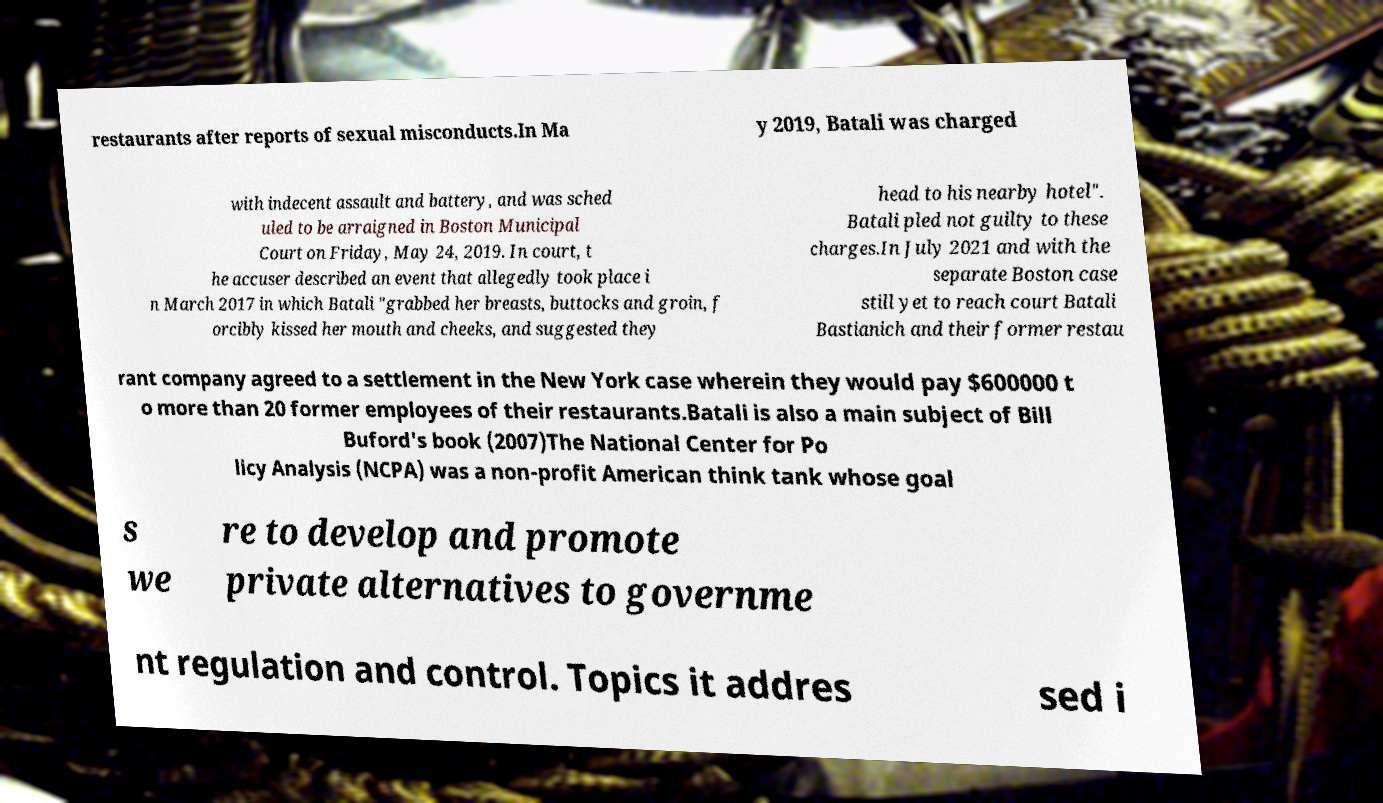I need the written content from this picture converted into text. Can you do that? restaurants after reports of sexual misconducts.In Ma y 2019, Batali was charged with indecent assault and battery, and was sched uled to be arraigned in Boston Municipal Court on Friday, May 24, 2019. In court, t he accuser described an event that allegedly took place i n March 2017 in which Batali "grabbed her breasts, buttocks and groin, f orcibly kissed her mouth and cheeks, and suggested they head to his nearby hotel". Batali pled not guilty to these charges.In July 2021 and with the separate Boston case still yet to reach court Batali Bastianich and their former restau rant company agreed to a settlement in the New York case wherein they would pay $600000 t o more than 20 former employees of their restaurants.Batali is also a main subject of Bill Buford's book (2007)The National Center for Po licy Analysis (NCPA) was a non-profit American think tank whose goal s we re to develop and promote private alternatives to governme nt regulation and control. Topics it addres sed i 